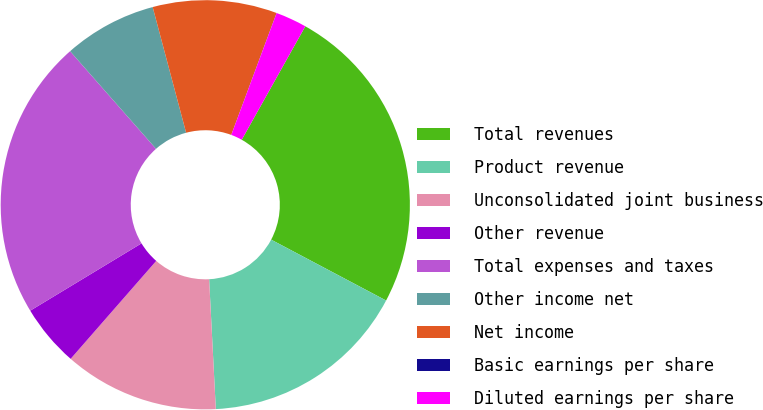Convert chart. <chart><loc_0><loc_0><loc_500><loc_500><pie_chart><fcel>Total revenues<fcel>Product revenue<fcel>Unconsolidated joint business<fcel>Other revenue<fcel>Total expenses and taxes<fcel>Other income net<fcel>Net income<fcel>Basic earnings per share<fcel>Diluted earnings per share<nl><fcel>24.62%<fcel>16.43%<fcel>12.25%<fcel>4.91%<fcel>22.17%<fcel>7.35%<fcel>9.8%<fcel>0.01%<fcel>2.46%<nl></chart> 